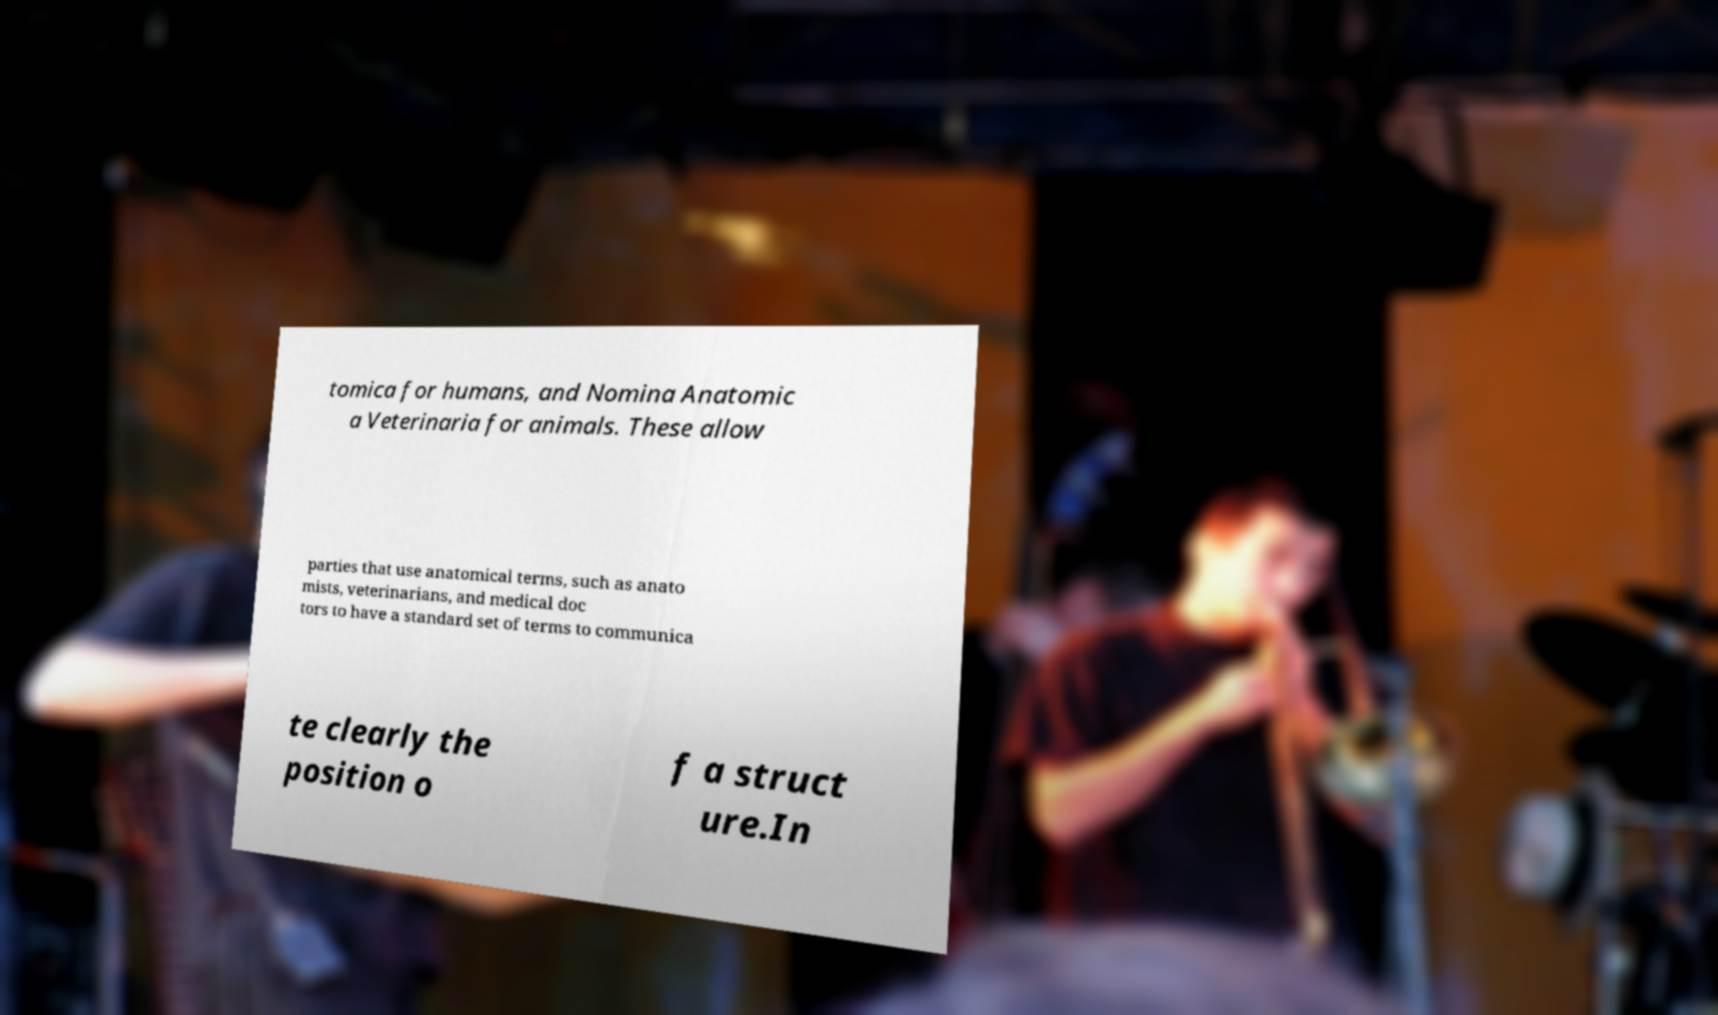For documentation purposes, I need the text within this image transcribed. Could you provide that? tomica for humans, and Nomina Anatomic a Veterinaria for animals. These allow parties that use anatomical terms, such as anato mists, veterinarians, and medical doc tors to have a standard set of terms to communica te clearly the position o f a struct ure.In 